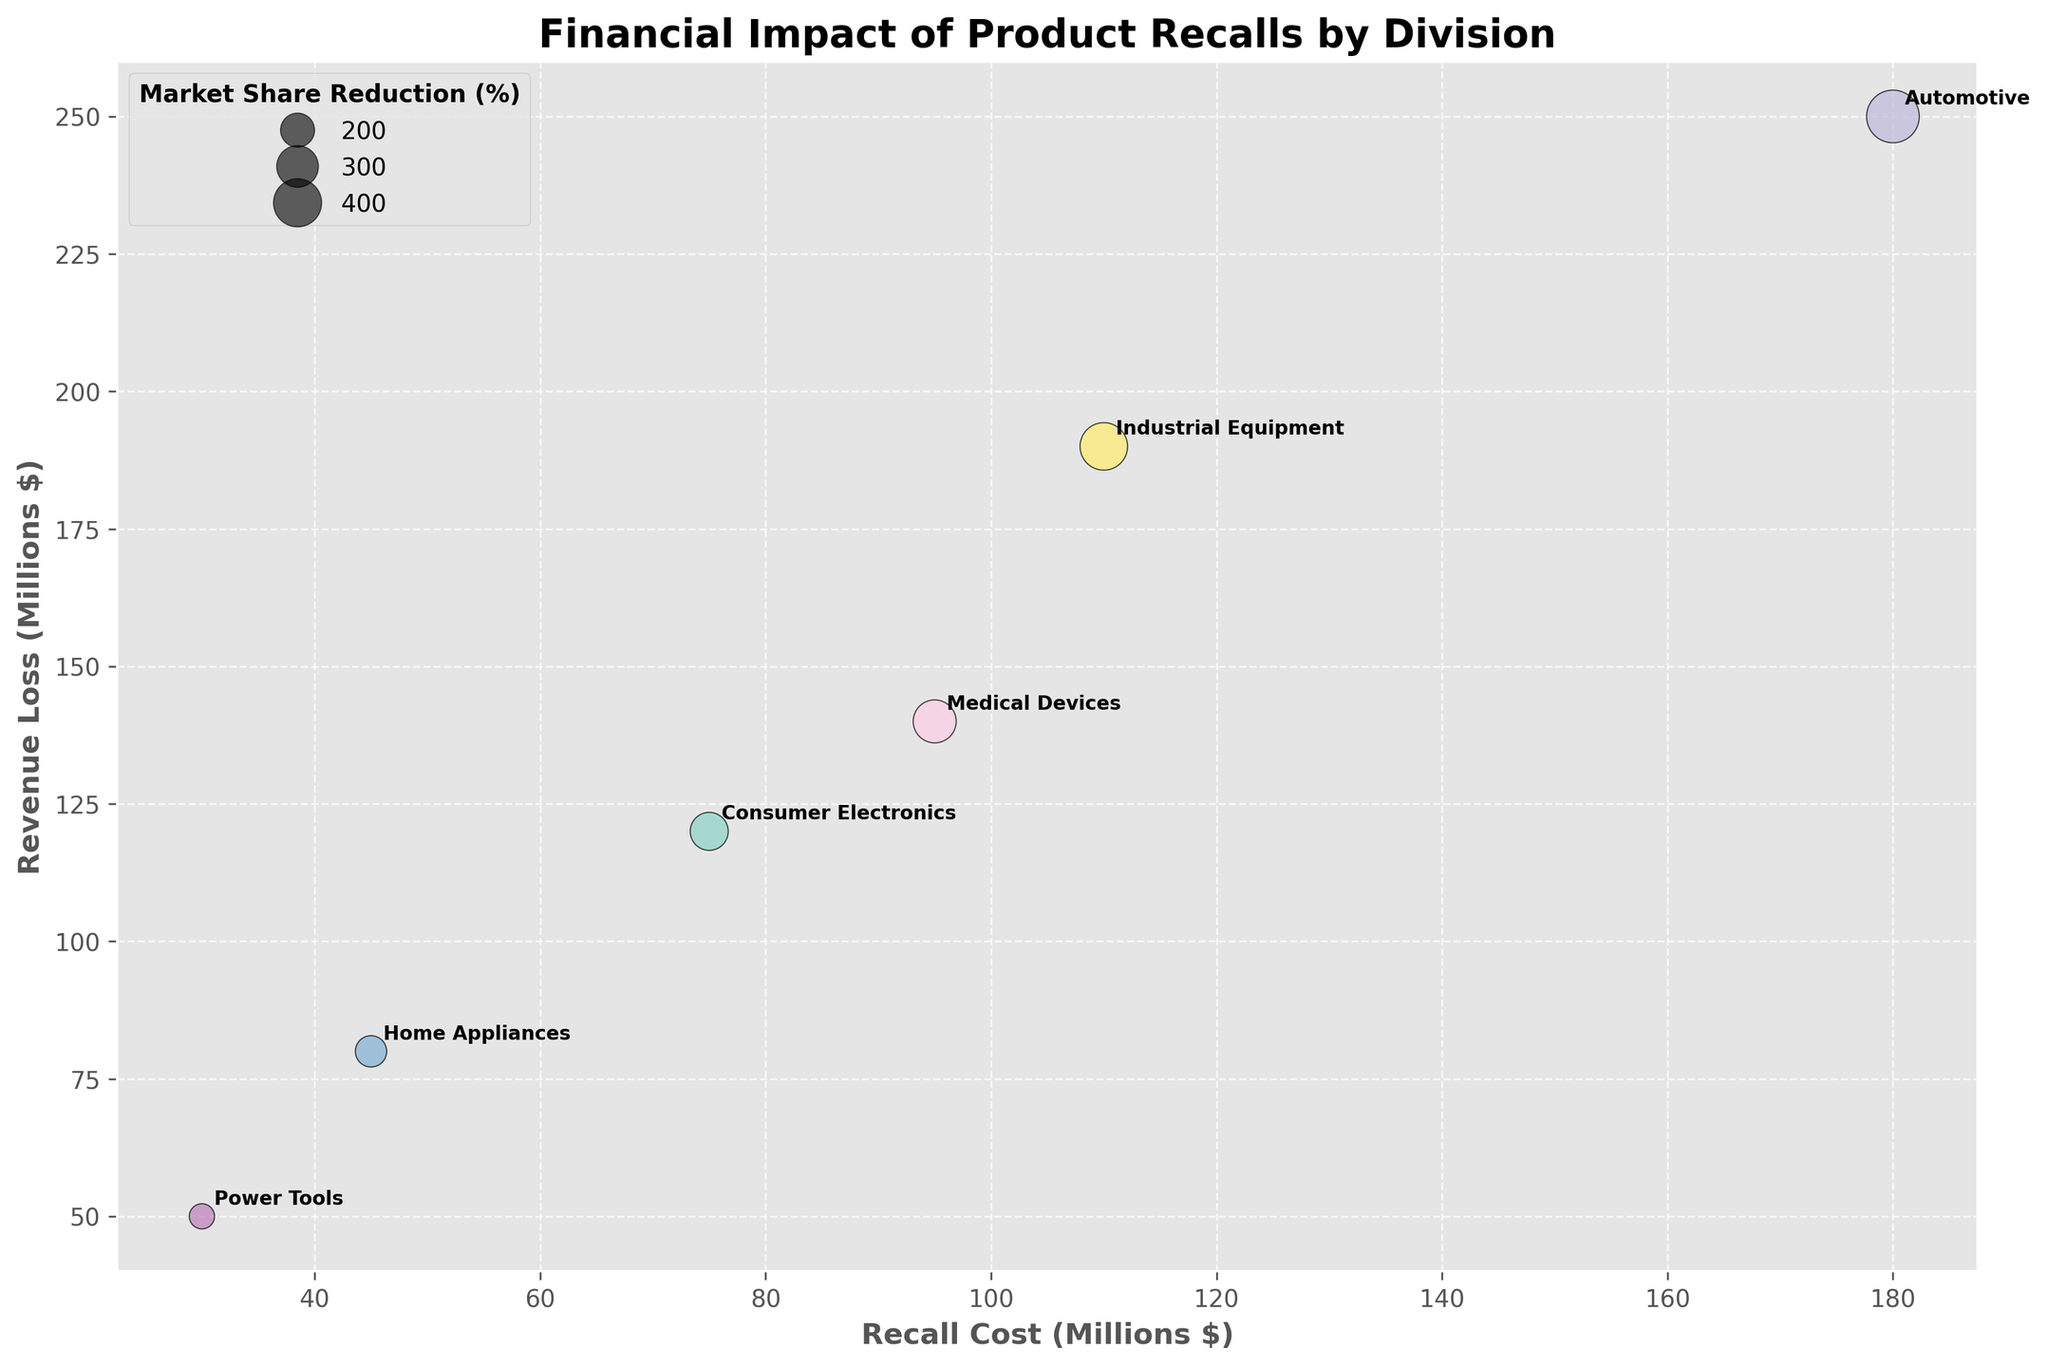What is the title of the plot? Above the plot, it reads "Financial Impact of Product Recalls by Division", indicating the financial effects of recalls on different divisions.
Answer: Financial Impact of Product Recalls by Division What do the sizes of the bubbles represent? The legend on the top left corner titles "Market Share Reduction (%)" and bubble sizes vary accordingly, indicating the market share reduction in percentage.
Answer: Market Share Reduction (%) How many divisions are represented in the plot? Each bubble annotates a division name, counting the unique labels gives six.
Answer: Six Which division incurred the highest recall cost? Observe the x-axis for the highest value. The bubble for "Automotive" is annotated at $180 million.
Answer: Automotive What's the relationship between recall cost and revenue loss for Consumer Electronics? Locate the "Consumer Electronics" bubble, noting its position on the x-axis ($75 million) and y-axis ($120 million).
Answer: Recall Cost: $75 million, Revenue Loss: $120 million Which division had the lowest market share reduction? The smallest bubble, annotated as "Power Tools", shows the lowest market share reduction (1.1%).
Answer: Power Tools Is there any division that lies near the midpoint of both axes? Find bubbles around the center of the plot, placing "Medical Devices" (x: $95M, y: $140M) closest.
Answer: Medical Devices How does the recall cost of Home Appliances compare to Industrial Equipment? Compare x-axis positions: "Home Appliances" at $45 million and "Industrial Equipment" at $110 million.
Answer: Home Appliances: $45 million, Industrial Equipment: $110 million Which division has the largest bubble? The bubble for the "Automotive" division appears largest, indicating the highest market share reduction (4.8%).
Answer: Automotive What’s the total market share reduction (%) for all divisions combined? Add up the percentages: 2.5% (Consumer Electronics) + 4.8% (Automotive) + 1.7% (Home Appliances) + 3.2% (Medical Devices) + 1.1% (Power Tools) + 3.9% (Industrial Equipment) = 17.2%.
Answer: 17.2% 